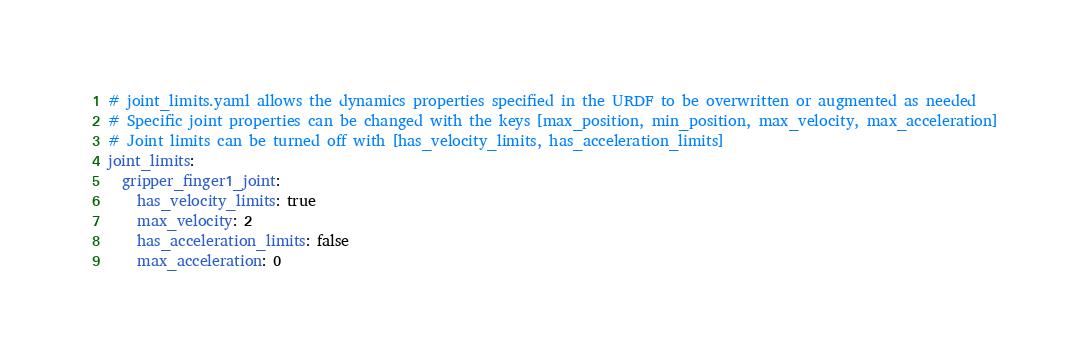Convert code to text. <code><loc_0><loc_0><loc_500><loc_500><_YAML_># joint_limits.yaml allows the dynamics properties specified in the URDF to be overwritten or augmented as needed
# Specific joint properties can be changed with the keys [max_position, min_position, max_velocity, max_acceleration]
# Joint limits can be turned off with [has_velocity_limits, has_acceleration_limits]
joint_limits:
  gripper_finger1_joint:
    has_velocity_limits: true
    max_velocity: 2
    has_acceleration_limits: false
    max_acceleration: 0
</code> 